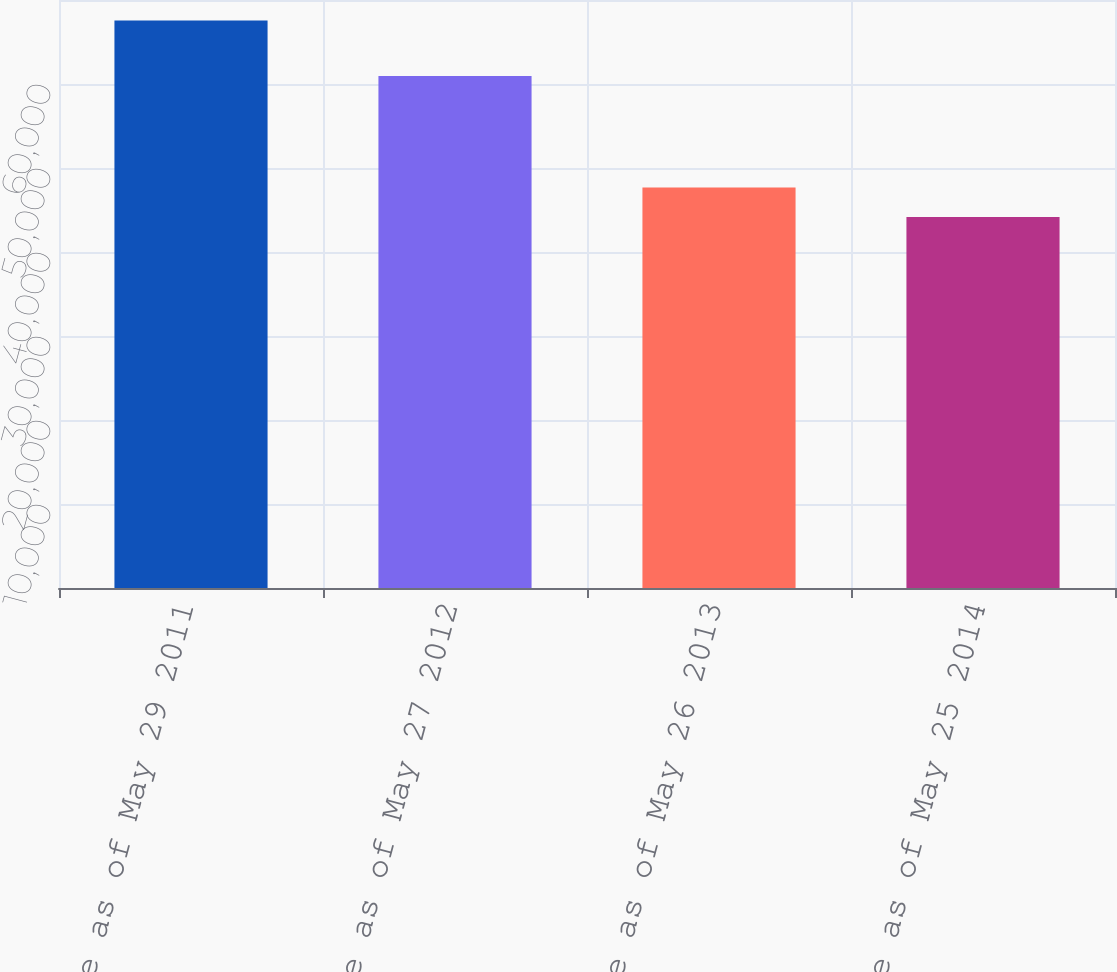Convert chart. <chart><loc_0><loc_0><loc_500><loc_500><bar_chart><fcel>Balance as of May 29 2011<fcel>Balance as of May 27 2012<fcel>Balance as of May 26 2013<fcel>Balance as of May 25 2014<nl><fcel>67547.3<fcel>60942.7<fcel>47672.1<fcel>44169<nl></chart> 